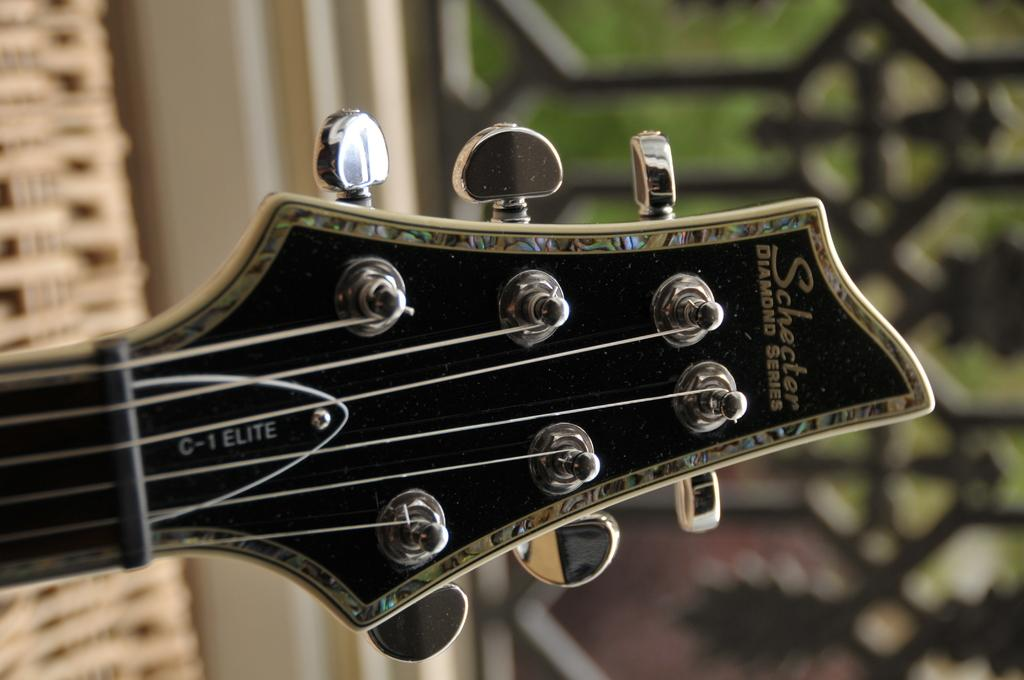What is the main subject of the image? The main subject of the image is a guitar head. What specific features can be seen on the guitar head? There are tuners visible in the image. What book is the guitar head reading in the image? There is no book present in the image, as it features a guitar head with tuners. 